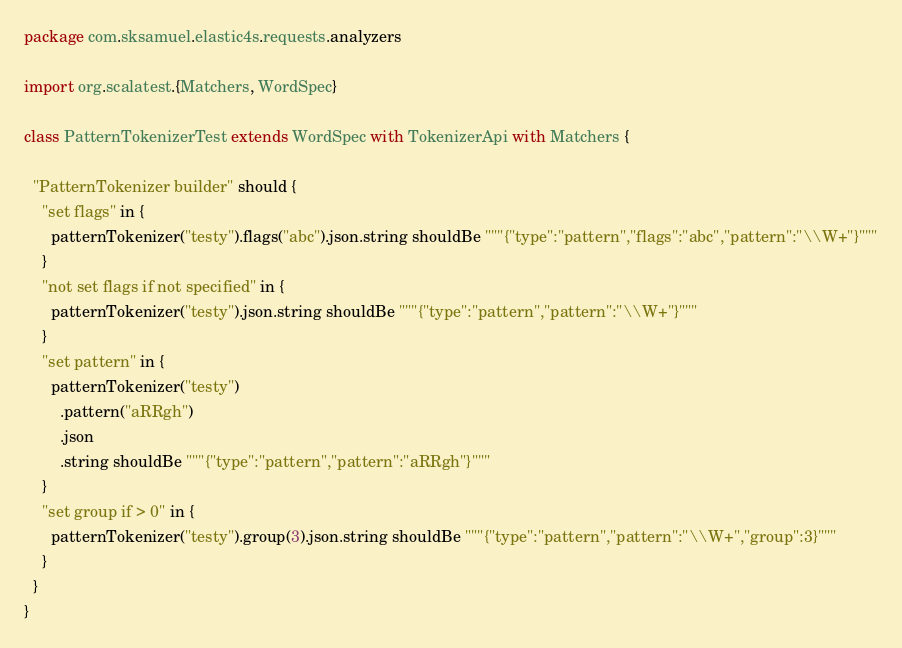Convert code to text. <code><loc_0><loc_0><loc_500><loc_500><_Scala_>package com.sksamuel.elastic4s.requests.analyzers

import org.scalatest.{Matchers, WordSpec}

class PatternTokenizerTest extends WordSpec with TokenizerApi with Matchers {

  "PatternTokenizer builder" should {
    "set flags" in {
      patternTokenizer("testy").flags("abc").json.string shouldBe """{"type":"pattern","flags":"abc","pattern":"\\W+"}"""
    }
    "not set flags if not specified" in {
      patternTokenizer("testy").json.string shouldBe """{"type":"pattern","pattern":"\\W+"}"""
    }
    "set pattern" in {
      patternTokenizer("testy")
        .pattern("aRRgh")
        .json
        .string shouldBe """{"type":"pattern","pattern":"aRRgh"}"""
    }
    "set group if > 0" in {
      patternTokenizer("testy").group(3).json.string shouldBe """{"type":"pattern","pattern":"\\W+","group":3}"""
    }
  }
}
</code> 